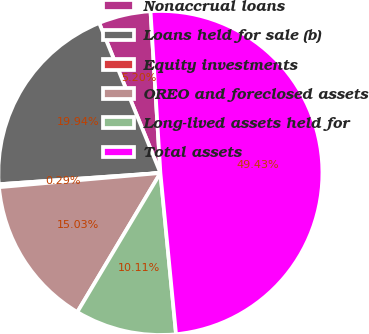Convert chart to OTSL. <chart><loc_0><loc_0><loc_500><loc_500><pie_chart><fcel>Nonaccrual loans<fcel>Loans held for sale (b)<fcel>Equity investments<fcel>OREO and foreclosed assets<fcel>Long-lived assets held for<fcel>Total assets<nl><fcel>5.2%<fcel>19.94%<fcel>0.29%<fcel>15.03%<fcel>10.11%<fcel>49.43%<nl></chart> 